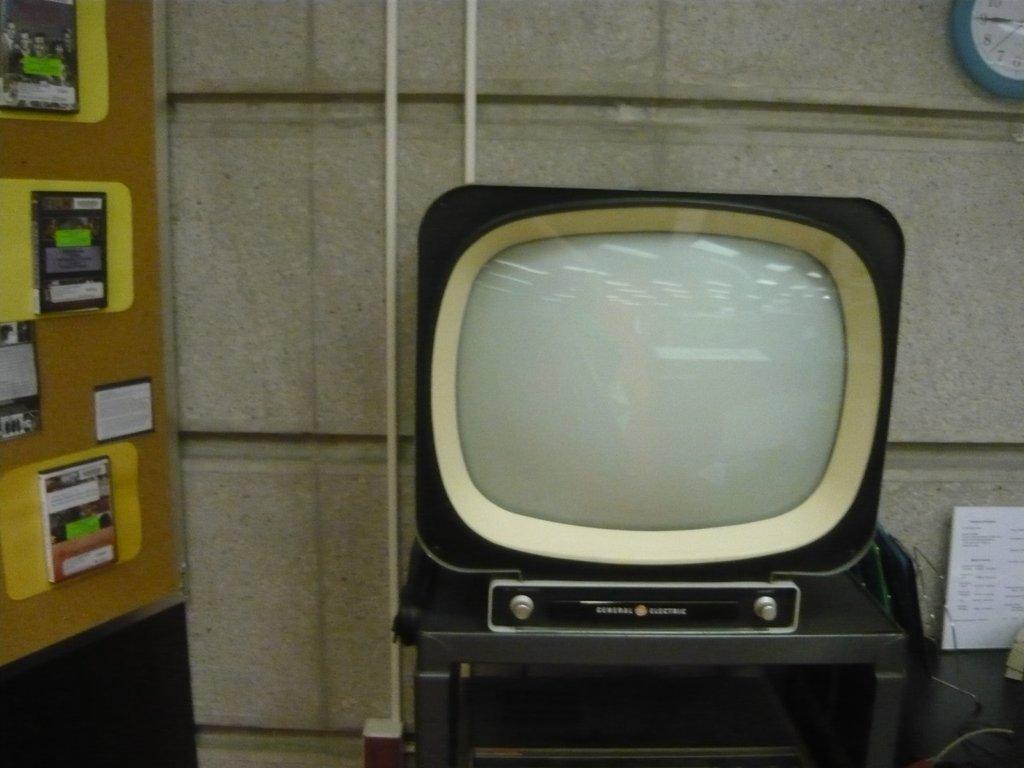Can you describe this image briefly? We can see television on table and we can see clock and board on wall. Here we can see books on surface. 